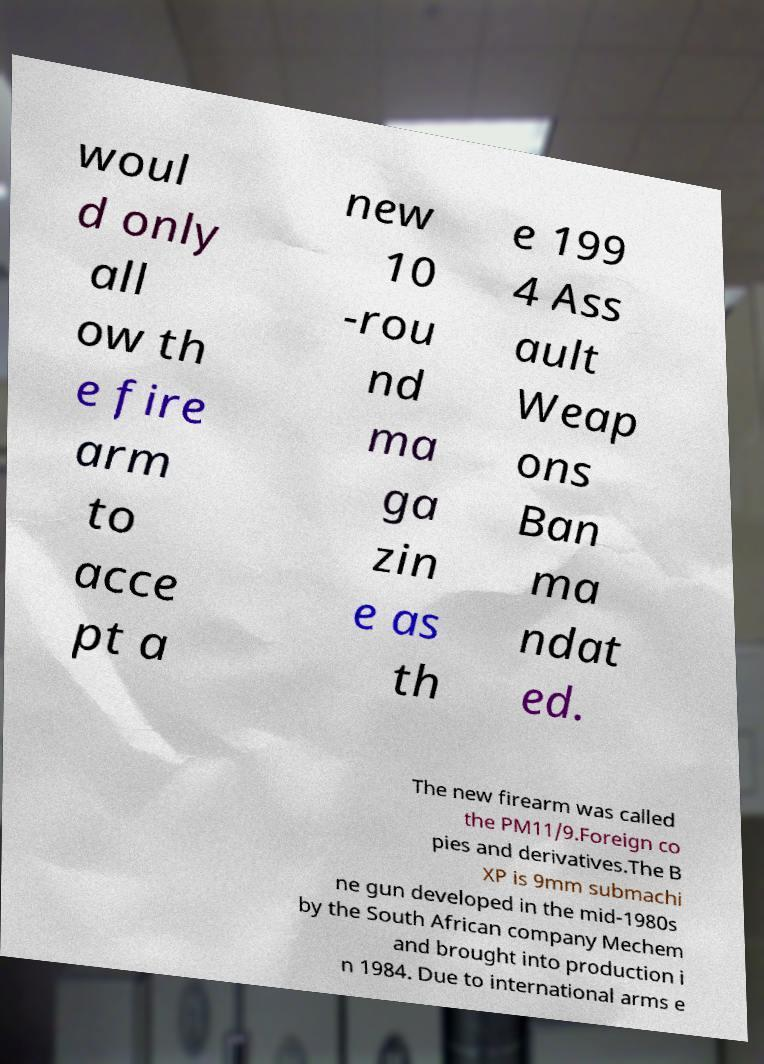What messages or text are displayed in this image? I need them in a readable, typed format. woul d only all ow th e fire arm to acce pt a new 10 -rou nd ma ga zin e as th e 199 4 Ass ault Weap ons Ban ma ndat ed. The new firearm was called the PM11/9.Foreign co pies and derivatives.The B XP is 9mm submachi ne gun developed in the mid-1980s by the South African company Mechem and brought into production i n 1984. Due to international arms e 